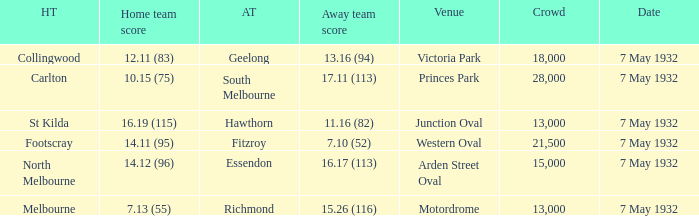What is the home team for victoria park? Collingwood. Would you be able to parse every entry in this table? {'header': ['HT', 'Home team score', 'AT', 'Away team score', 'Venue', 'Crowd', 'Date'], 'rows': [['Collingwood', '12.11 (83)', 'Geelong', '13.16 (94)', 'Victoria Park', '18,000', '7 May 1932'], ['Carlton', '10.15 (75)', 'South Melbourne', '17.11 (113)', 'Princes Park', '28,000', '7 May 1932'], ['St Kilda', '16.19 (115)', 'Hawthorn', '11.16 (82)', 'Junction Oval', '13,000', '7 May 1932'], ['Footscray', '14.11 (95)', 'Fitzroy', '7.10 (52)', 'Western Oval', '21,500', '7 May 1932'], ['North Melbourne', '14.12 (96)', 'Essendon', '16.17 (113)', 'Arden Street Oval', '15,000', '7 May 1932'], ['Melbourne', '7.13 (55)', 'Richmond', '15.26 (116)', 'Motordrome', '13,000', '7 May 1932']]} 